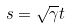<formula> <loc_0><loc_0><loc_500><loc_500>s = \sqrt { \gamma } t</formula> 